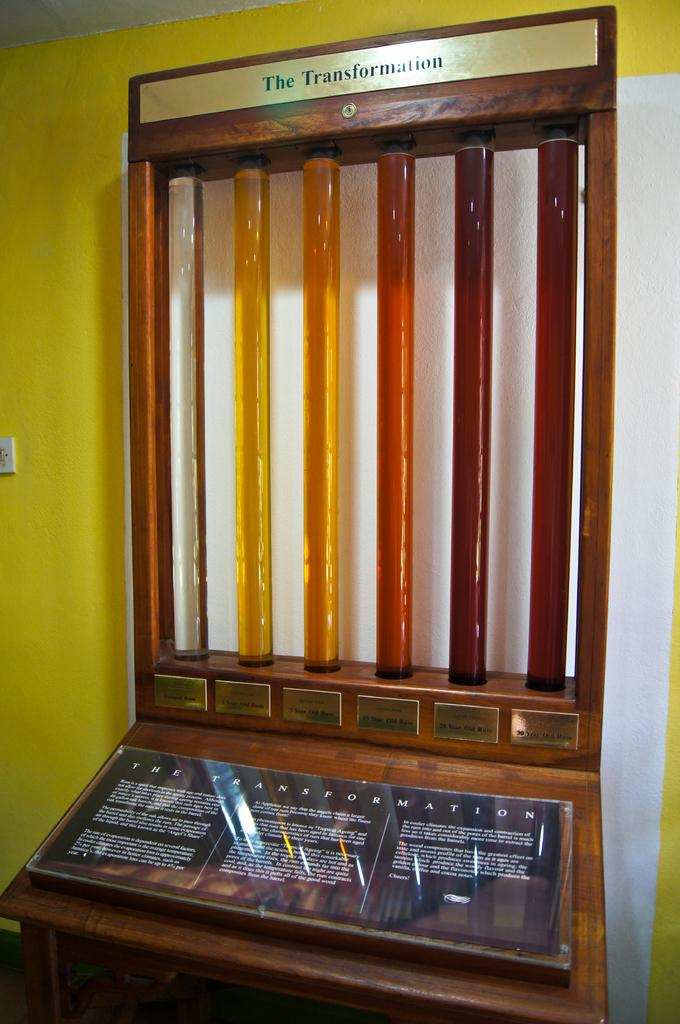What is the main subject of the image? The main subject of the image appears to be a drawer. Can you describe the background of the image? There is a wall visible in the background of the image. What type of boats are participating in the competition in the image? There are no boats or competitions present in the image; it features a drawer and a wall in the background. 